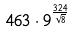<formula> <loc_0><loc_0><loc_500><loc_500>4 6 3 \cdot 9 ^ { \frac { 3 2 4 } { \sqrt { 8 } } }</formula> 